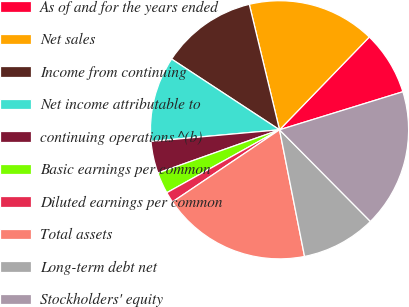Convert chart to OTSL. <chart><loc_0><loc_0><loc_500><loc_500><pie_chart><fcel>As of and for the years ended<fcel>Net sales<fcel>Income from continuing<fcel>Net income attributable to<fcel>continuing operations ^(b)<fcel>Basic earnings per common<fcel>Diluted earnings per common<fcel>Total assets<fcel>Long-term debt net<fcel>Stockholders' equity<nl><fcel>8.0%<fcel>16.0%<fcel>12.0%<fcel>10.67%<fcel>4.0%<fcel>2.67%<fcel>1.33%<fcel>18.67%<fcel>9.33%<fcel>17.33%<nl></chart> 